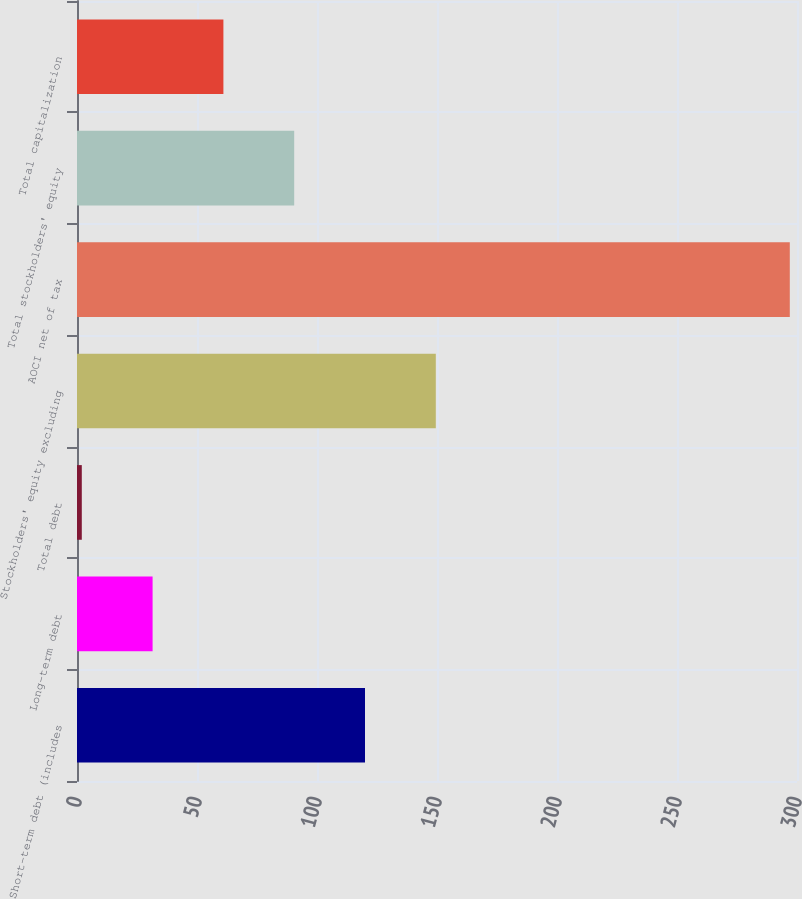Convert chart. <chart><loc_0><loc_0><loc_500><loc_500><bar_chart><fcel>Short-term debt (includes<fcel>Long-term debt<fcel>Total debt<fcel>Stockholders' equity excluding<fcel>AOCI net of tax<fcel>Total stockholders' equity<fcel>Total capitalization<nl><fcel>120<fcel>31.5<fcel>2<fcel>149.5<fcel>297<fcel>90.5<fcel>61<nl></chart> 